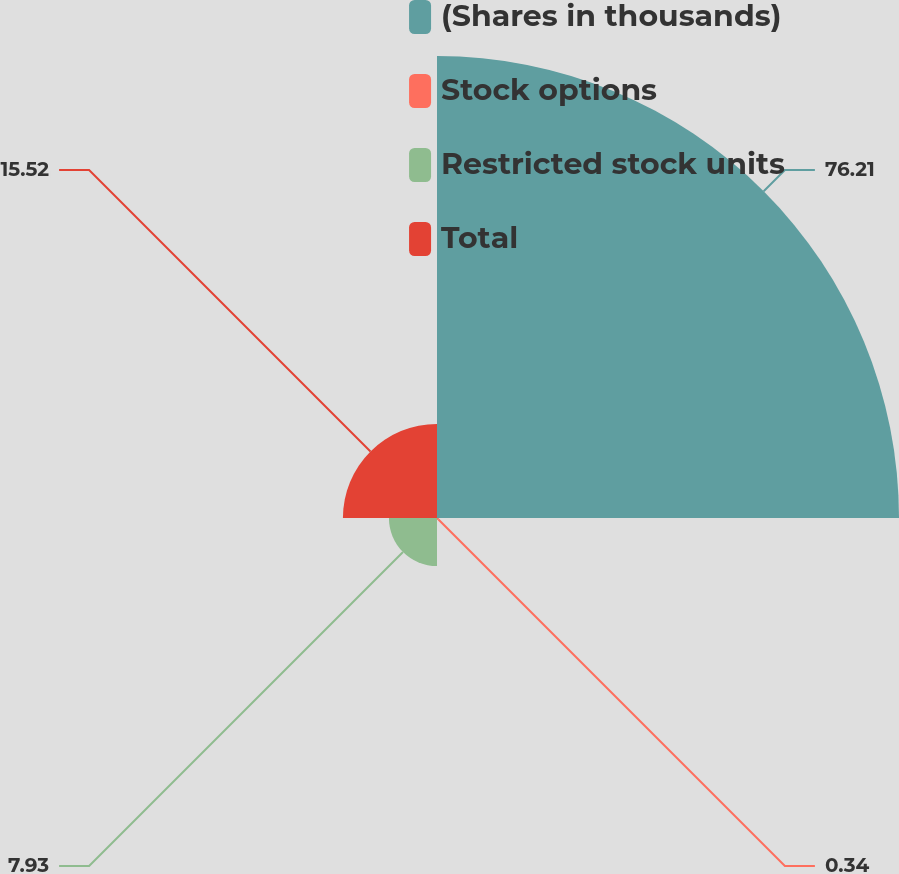Convert chart to OTSL. <chart><loc_0><loc_0><loc_500><loc_500><pie_chart><fcel>(Shares in thousands)<fcel>Stock options<fcel>Restricted stock units<fcel>Total<nl><fcel>76.21%<fcel>0.34%<fcel>7.93%<fcel>15.52%<nl></chart> 